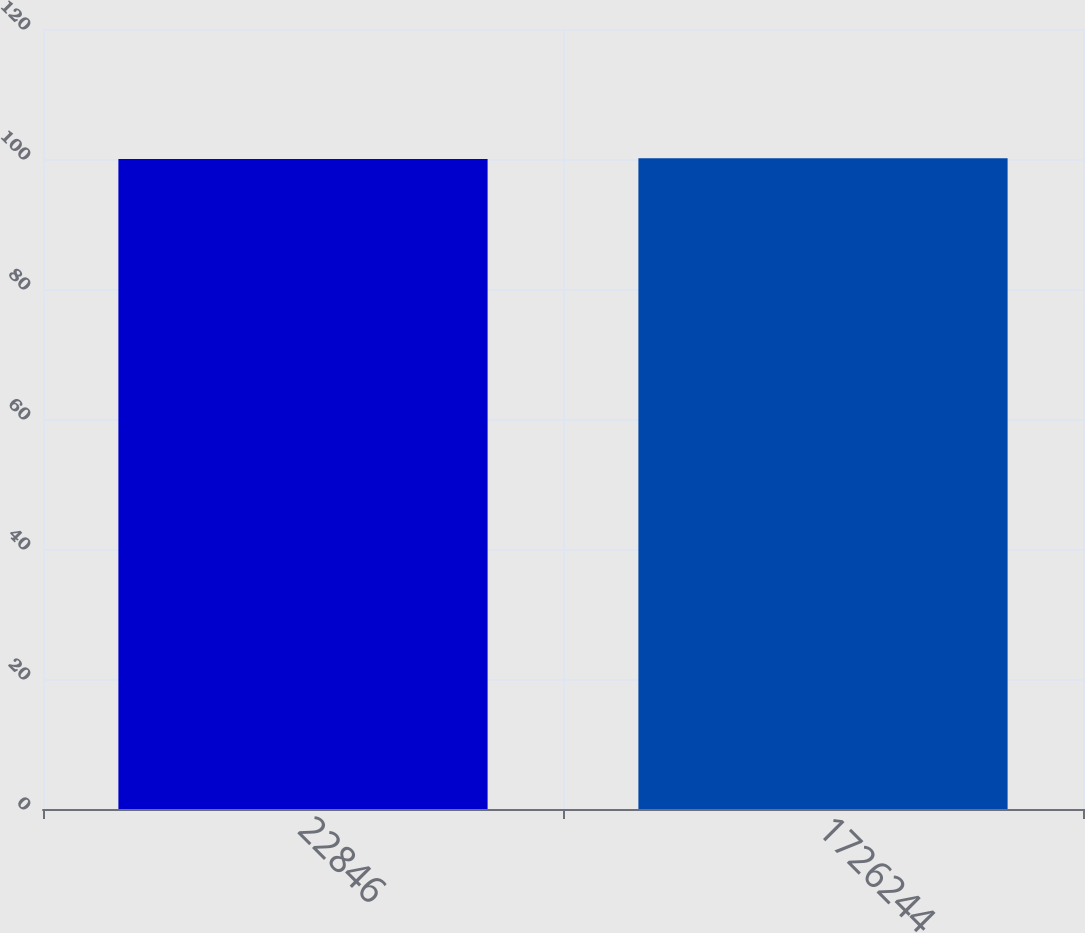Convert chart to OTSL. <chart><loc_0><loc_0><loc_500><loc_500><bar_chart><fcel>22846<fcel>1726244<nl><fcel>100<fcel>100.1<nl></chart> 